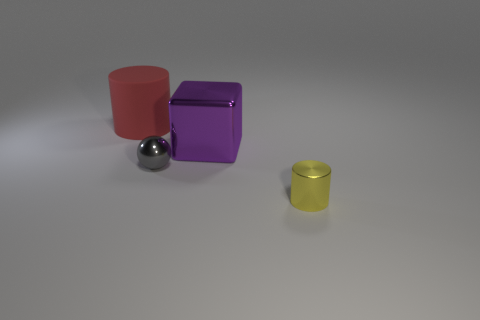Add 4 purple blocks. How many objects exist? 8 Subtract all blocks. How many objects are left? 3 Subtract 0 yellow cubes. How many objects are left? 4 Subtract all small yellow cylinders. Subtract all yellow things. How many objects are left? 2 Add 2 gray shiny objects. How many gray shiny objects are left? 3 Add 1 metallic cubes. How many metallic cubes exist? 2 